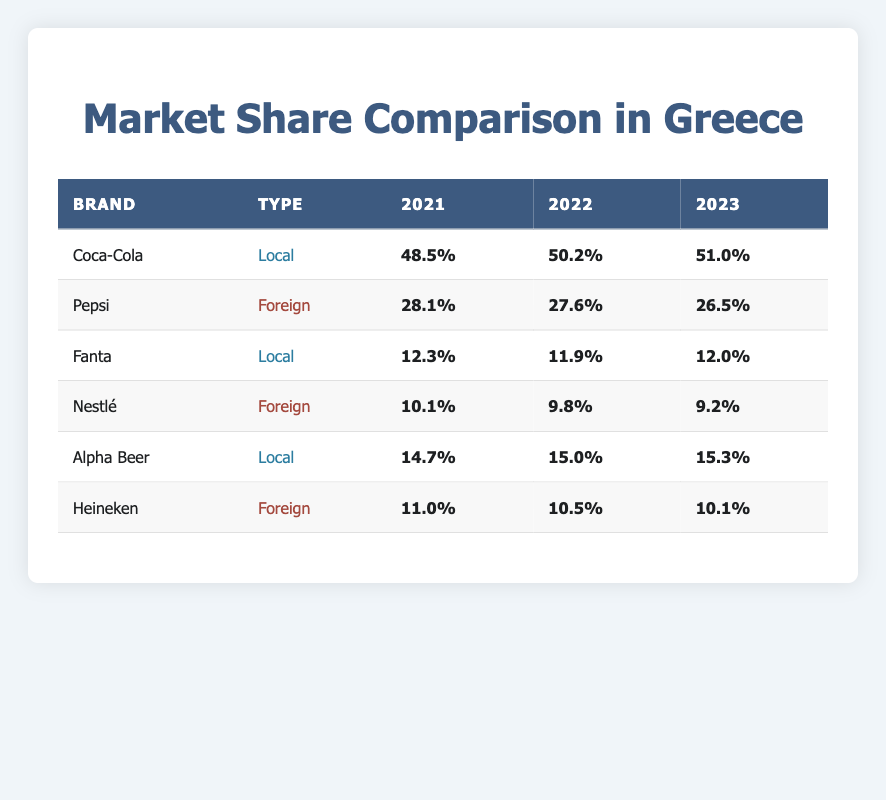What was the market share of Coca-Cola in 2022? Referring to the table, Coca-Cola's market share in 2022 is listed as 50.2%.
Answer: 50.2% Which brand had the highest market share in 2021? In 2021, Coca-Cola had the highest market share at 48.5%, compared to other brands listed.
Answer: Coca-Cola What is the percentage difference in market share for Pepsi from 2021 to 2023? The market share for Pepsi in 2021 is 28.1% and in 2023 it is 26.5%. The difference is 28.1% - 26.5% = 1.6%.
Answer: 1.6% Did Nestlé's market share increase from 2021 to 2023? Nestlé's market shares were 10.1% in 2021 and decreased to 9.2% in 2023, so it did not increase.
Answer: No What is the average market share of local brands in 2023? The local brands in 2023 are Coca-Cola (51.0%), Fanta (12.0%), and Alpha Beer (15.3%). The average is (51.0 + 12.0 + 15.3) / 3 = 78.3 / 3 = 26.1%.
Answer: 26.1% Which foreign brand had a market share closer to 10% in 2023? In 2023, the foreign brands are Pepsi at 26.5%, Nestlé at 9.2%, and Heineken at 10.1%. Among these, Nestlé is closest to 10%.
Answer: Nestlé How much did Alpha Beer’s market share grow from 2021 to 2023? Alpha Beer had a market share of 14.7% in 2021 and 15.3% in 2023. The growth is 15.3% - 14.7% = 0.6%.
Answer: 0.6% Is the market share of Fanta higher than that of Heineken for any year listed? Fanta's market shares are 12.3% (2021), 11.9% (2022), and 12.0% (2023), while Heineken's are 11.0% (2021), 10.5% (2022), and 10.1% (2023). Fanta is higher than Heineken in all years.
Answer: Yes Which brand had the largest decline in market share from 2021 to 2022? Nestlé declined from 10.1% in 2021 to 9.8% in 2022, a decline of 0.3%. Other brands either increased or declined less.
Answer: Nestlé What was the total market share percentage for all local brands in 2022? The local brands in 2022 (Coca-Cola, Fanta, and Alpha Beer) had market shares of 50.2%, 11.9%, and 15.0% respectively. Total is 50.2 + 11.9 + 15.0 = 77.1%.
Answer: 77.1% 